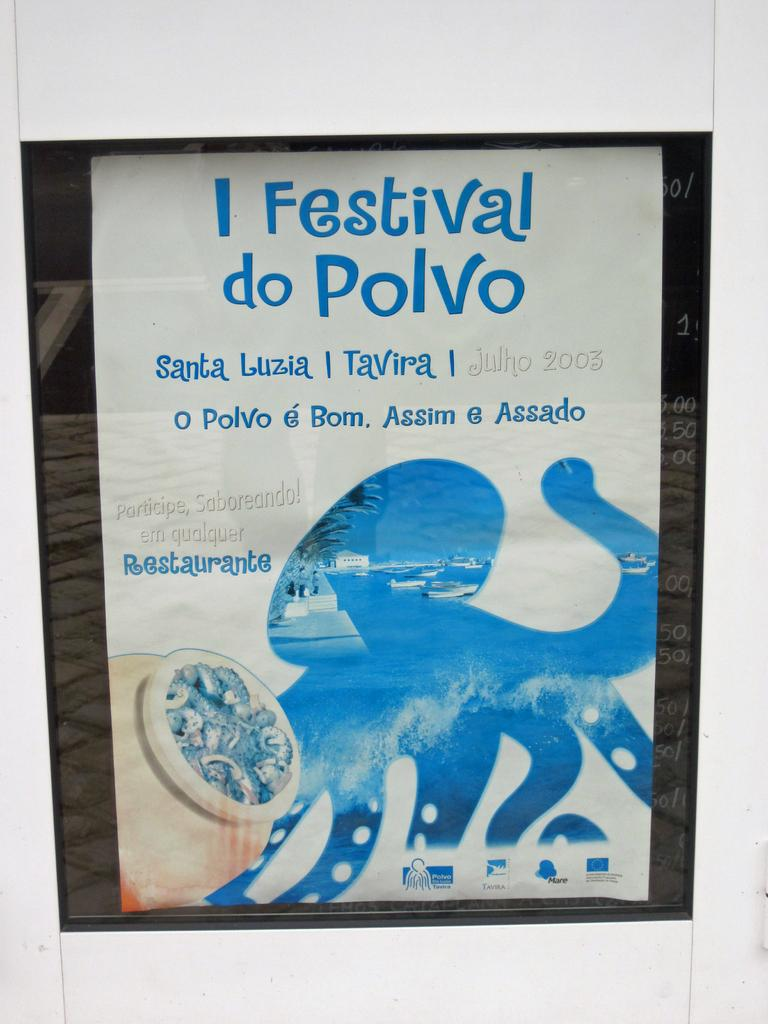<image>
Create a compact narrative representing the image presented. A book titled I Festival do Polvo with the outline of an octupus on it. 